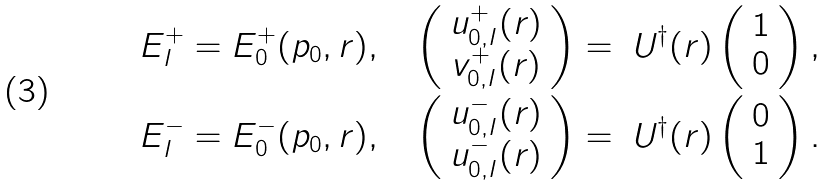<formula> <loc_0><loc_0><loc_500><loc_500>E ^ { + } _ { I } = E _ { 0 } ^ { + } ( { p } _ { 0 } , { r } ) , \quad & \left ( \begin{array} { c } u _ { 0 , { I } } ^ { + } ( { r } ) \\ v _ { 0 , { I } } ^ { + } ( { r } ) \end{array} \right ) = \ U ^ { \dagger } ( { r } ) \left ( \begin{array} { c } 1 \\ 0 \end{array} \right ) , \\ E ^ { - } _ { I } = E _ { 0 } ^ { - } ( { p } _ { 0 } , { r } ) , \quad & \left ( \begin{array} { c } u _ { 0 , { I } } ^ { - } ( { r } ) \\ u _ { 0 , { I } } ^ { - } ( { r } ) \end{array} \right ) = \ U ^ { \dagger } ( { r } ) \left ( \begin{array} { c } 0 \\ 1 \end{array} \right ) .</formula> 